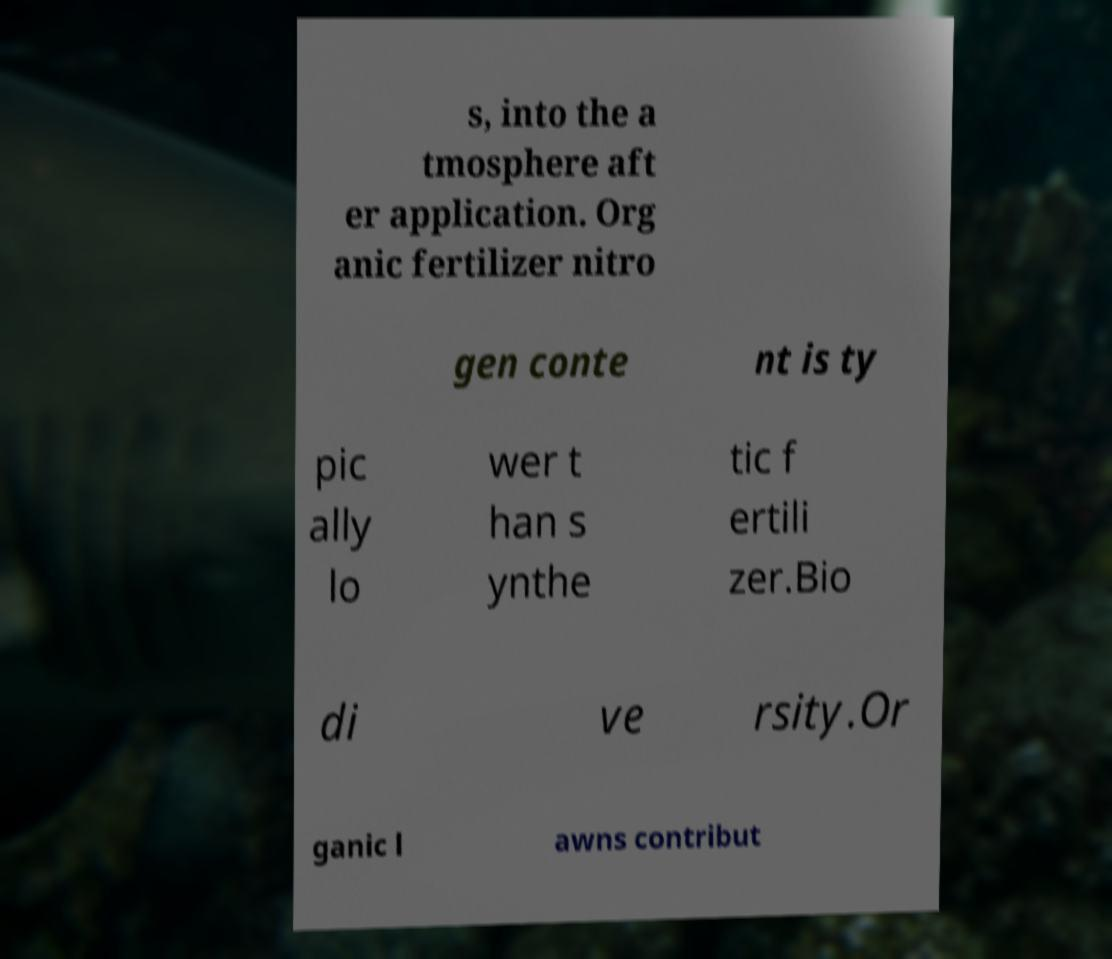Could you extract and type out the text from this image? s, into the a tmosphere aft er application. Org anic fertilizer nitro gen conte nt is ty pic ally lo wer t han s ynthe tic f ertili zer.Bio di ve rsity.Or ganic l awns contribut 